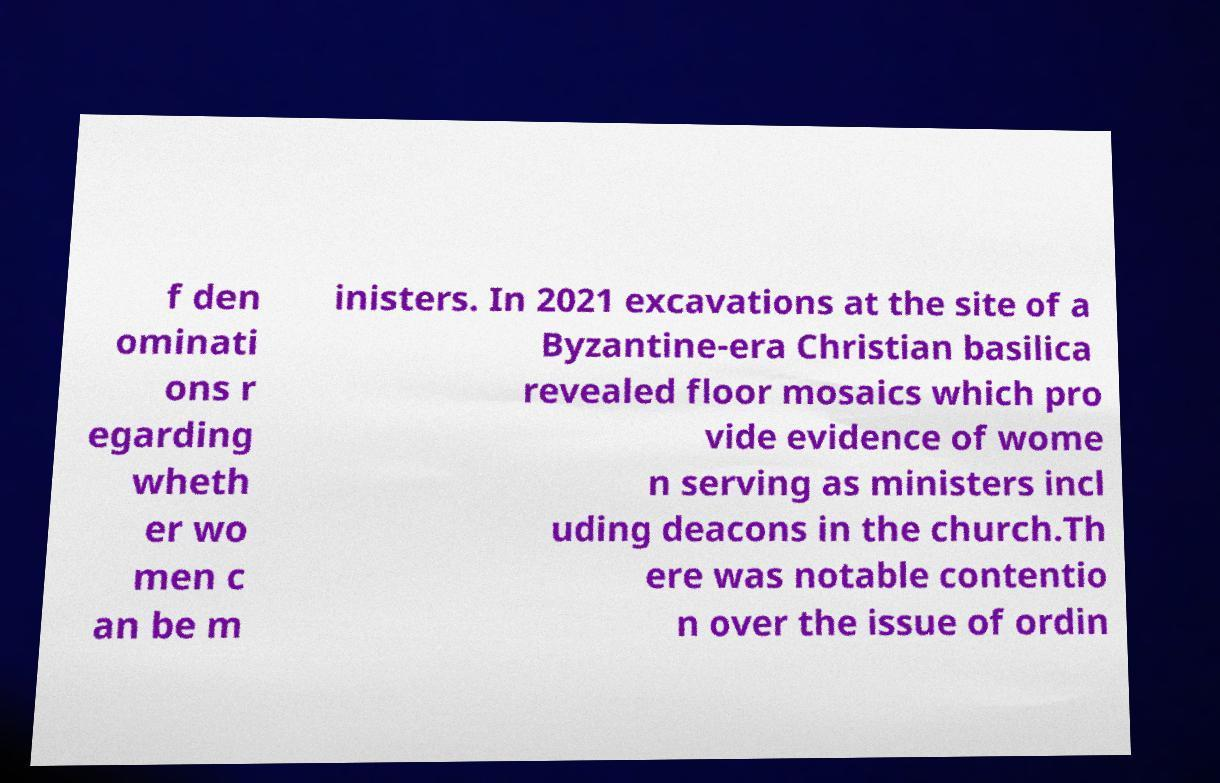Could you extract and type out the text from this image? f den ominati ons r egarding wheth er wo men c an be m inisters. In 2021 excavations at the site of a Byzantine-era Christian basilica revealed floor mosaics which pro vide evidence of wome n serving as ministers incl uding deacons in the church.Th ere was notable contentio n over the issue of ordin 